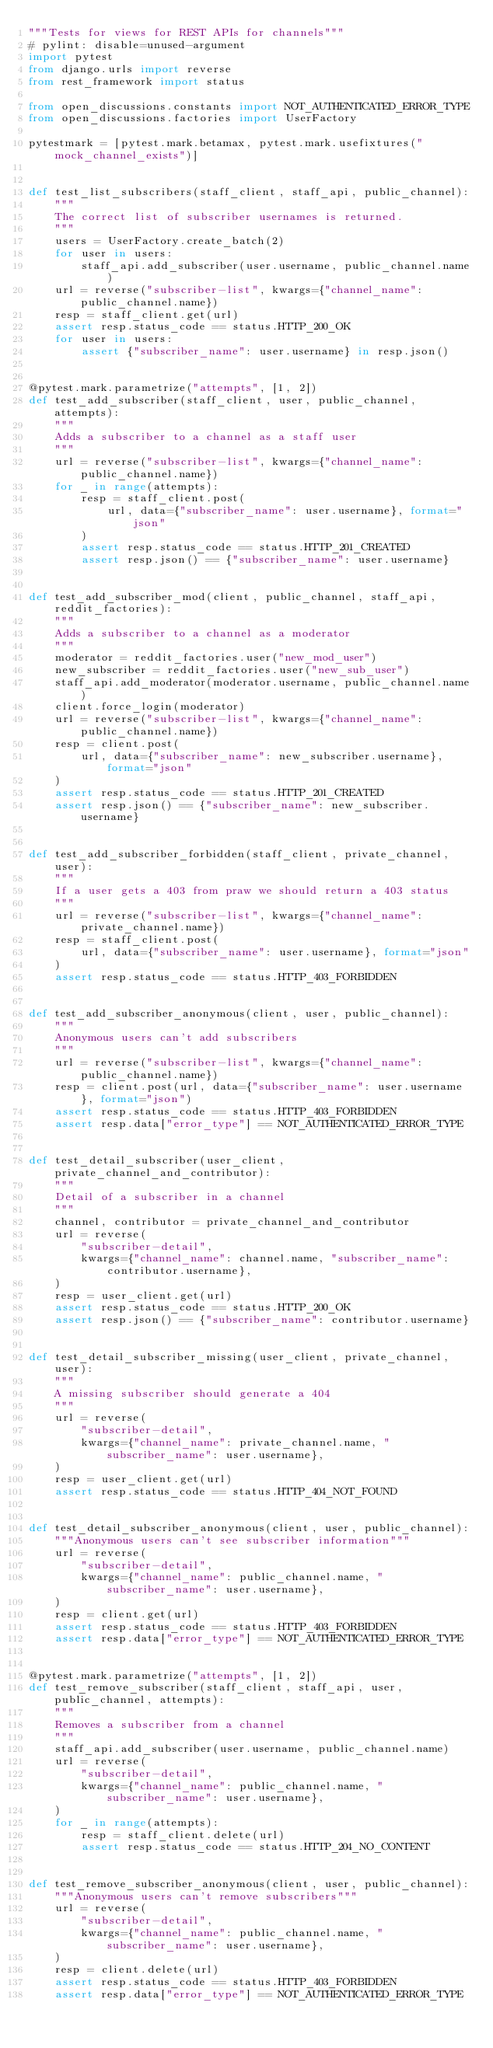<code> <loc_0><loc_0><loc_500><loc_500><_Python_>"""Tests for views for REST APIs for channels"""
# pylint: disable=unused-argument
import pytest
from django.urls import reverse
from rest_framework import status

from open_discussions.constants import NOT_AUTHENTICATED_ERROR_TYPE
from open_discussions.factories import UserFactory

pytestmark = [pytest.mark.betamax, pytest.mark.usefixtures("mock_channel_exists")]


def test_list_subscribers(staff_client, staff_api, public_channel):
    """
    The correct list of subscriber usernames is returned.
    """
    users = UserFactory.create_batch(2)
    for user in users:
        staff_api.add_subscriber(user.username, public_channel.name)
    url = reverse("subscriber-list", kwargs={"channel_name": public_channel.name})
    resp = staff_client.get(url)
    assert resp.status_code == status.HTTP_200_OK
    for user in users:
        assert {"subscriber_name": user.username} in resp.json()


@pytest.mark.parametrize("attempts", [1, 2])
def test_add_subscriber(staff_client, user, public_channel, attempts):
    """
    Adds a subscriber to a channel as a staff user
    """
    url = reverse("subscriber-list", kwargs={"channel_name": public_channel.name})
    for _ in range(attempts):
        resp = staff_client.post(
            url, data={"subscriber_name": user.username}, format="json"
        )
        assert resp.status_code == status.HTTP_201_CREATED
        assert resp.json() == {"subscriber_name": user.username}


def test_add_subscriber_mod(client, public_channel, staff_api, reddit_factories):
    """
    Adds a subscriber to a channel as a moderator
    """
    moderator = reddit_factories.user("new_mod_user")
    new_subscriber = reddit_factories.user("new_sub_user")
    staff_api.add_moderator(moderator.username, public_channel.name)
    client.force_login(moderator)
    url = reverse("subscriber-list", kwargs={"channel_name": public_channel.name})
    resp = client.post(
        url, data={"subscriber_name": new_subscriber.username}, format="json"
    )
    assert resp.status_code == status.HTTP_201_CREATED
    assert resp.json() == {"subscriber_name": new_subscriber.username}


def test_add_subscriber_forbidden(staff_client, private_channel, user):
    """
    If a user gets a 403 from praw we should return a 403 status
    """
    url = reverse("subscriber-list", kwargs={"channel_name": private_channel.name})
    resp = staff_client.post(
        url, data={"subscriber_name": user.username}, format="json"
    )
    assert resp.status_code == status.HTTP_403_FORBIDDEN


def test_add_subscriber_anonymous(client, user, public_channel):
    """
    Anonymous users can't add subscribers
    """
    url = reverse("subscriber-list", kwargs={"channel_name": public_channel.name})
    resp = client.post(url, data={"subscriber_name": user.username}, format="json")
    assert resp.status_code == status.HTTP_403_FORBIDDEN
    assert resp.data["error_type"] == NOT_AUTHENTICATED_ERROR_TYPE


def test_detail_subscriber(user_client, private_channel_and_contributor):
    """
    Detail of a subscriber in a channel
    """
    channel, contributor = private_channel_and_contributor
    url = reverse(
        "subscriber-detail",
        kwargs={"channel_name": channel.name, "subscriber_name": contributor.username},
    )
    resp = user_client.get(url)
    assert resp.status_code == status.HTTP_200_OK
    assert resp.json() == {"subscriber_name": contributor.username}


def test_detail_subscriber_missing(user_client, private_channel, user):
    """
    A missing subscriber should generate a 404
    """
    url = reverse(
        "subscriber-detail",
        kwargs={"channel_name": private_channel.name, "subscriber_name": user.username},
    )
    resp = user_client.get(url)
    assert resp.status_code == status.HTTP_404_NOT_FOUND


def test_detail_subscriber_anonymous(client, user, public_channel):
    """Anonymous users can't see subscriber information"""
    url = reverse(
        "subscriber-detail",
        kwargs={"channel_name": public_channel.name, "subscriber_name": user.username},
    )
    resp = client.get(url)
    assert resp.status_code == status.HTTP_403_FORBIDDEN
    assert resp.data["error_type"] == NOT_AUTHENTICATED_ERROR_TYPE


@pytest.mark.parametrize("attempts", [1, 2])
def test_remove_subscriber(staff_client, staff_api, user, public_channel, attempts):
    """
    Removes a subscriber from a channel
    """
    staff_api.add_subscriber(user.username, public_channel.name)
    url = reverse(
        "subscriber-detail",
        kwargs={"channel_name": public_channel.name, "subscriber_name": user.username},
    )
    for _ in range(attempts):
        resp = staff_client.delete(url)
        assert resp.status_code == status.HTTP_204_NO_CONTENT


def test_remove_subscriber_anonymous(client, user, public_channel):
    """Anonymous users can't remove subscribers"""
    url = reverse(
        "subscriber-detail",
        kwargs={"channel_name": public_channel.name, "subscriber_name": user.username},
    )
    resp = client.delete(url)
    assert resp.status_code == status.HTTP_403_FORBIDDEN
    assert resp.data["error_type"] == NOT_AUTHENTICATED_ERROR_TYPE
</code> 